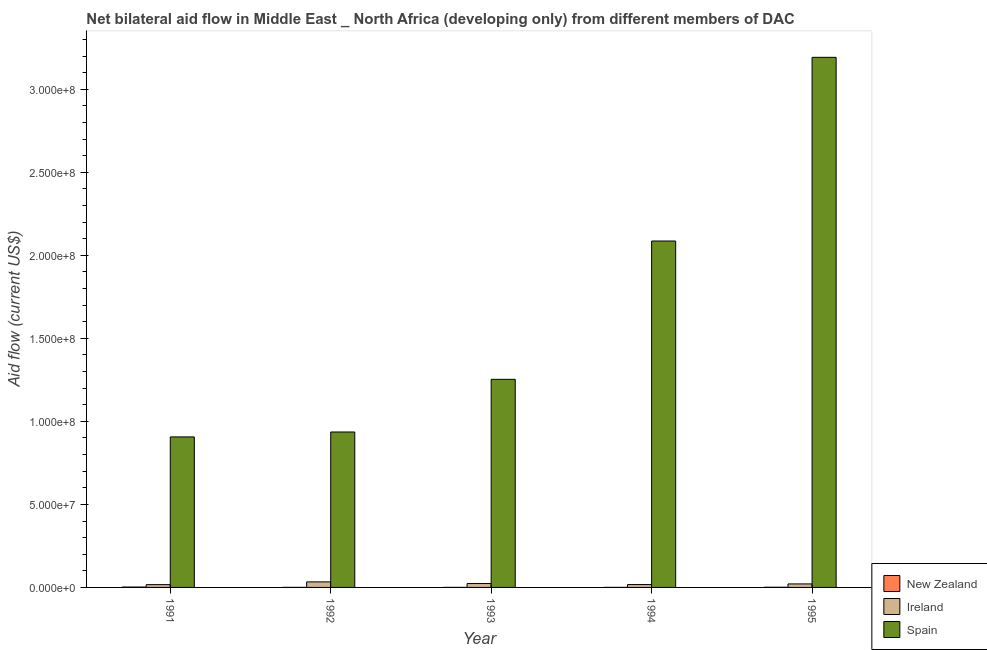How many different coloured bars are there?
Keep it short and to the point. 3. Are the number of bars per tick equal to the number of legend labels?
Provide a short and direct response. Yes. In how many cases, is the number of bars for a given year not equal to the number of legend labels?
Make the answer very short. 0. What is the amount of aid provided by spain in 1995?
Provide a short and direct response. 3.19e+08. Across all years, what is the maximum amount of aid provided by new zealand?
Offer a terse response. 2.20e+05. Across all years, what is the minimum amount of aid provided by spain?
Your answer should be very brief. 9.06e+07. In which year was the amount of aid provided by ireland minimum?
Your answer should be very brief. 1991. What is the total amount of aid provided by spain in the graph?
Your response must be concise. 8.37e+08. What is the difference between the amount of aid provided by new zealand in 1992 and that in 1995?
Your response must be concise. -7.00e+04. What is the difference between the amount of aid provided by ireland in 1994 and the amount of aid provided by new zealand in 1995?
Your answer should be very brief. -3.80e+05. What is the average amount of aid provided by ireland per year?
Offer a very short reply. 2.24e+06. In how many years, is the amount of aid provided by ireland greater than 260000000 US$?
Provide a succinct answer. 0. What is the ratio of the amount of aid provided by ireland in 1991 to that in 1993?
Provide a succinct answer. 0.72. What is the difference between the highest and the second highest amount of aid provided by spain?
Your response must be concise. 1.11e+08. What is the difference between the highest and the lowest amount of aid provided by spain?
Provide a succinct answer. 2.29e+08. In how many years, is the amount of aid provided by spain greater than the average amount of aid provided by spain taken over all years?
Offer a terse response. 2. Is the sum of the amount of aid provided by ireland in 1991 and 1992 greater than the maximum amount of aid provided by new zealand across all years?
Ensure brevity in your answer.  Yes. What does the 1st bar from the left in 1995 represents?
Your response must be concise. New Zealand. What does the 2nd bar from the right in 1994 represents?
Your answer should be very brief. Ireland. Are all the bars in the graph horizontal?
Offer a terse response. No. How many years are there in the graph?
Your answer should be very brief. 5. Are the values on the major ticks of Y-axis written in scientific E-notation?
Offer a terse response. Yes. Does the graph contain any zero values?
Keep it short and to the point. No. Where does the legend appear in the graph?
Your answer should be very brief. Bottom right. How are the legend labels stacked?
Your answer should be compact. Vertical. What is the title of the graph?
Offer a very short reply. Net bilateral aid flow in Middle East _ North Africa (developing only) from different members of DAC. Does "Capital account" appear as one of the legend labels in the graph?
Your response must be concise. No. What is the label or title of the Y-axis?
Ensure brevity in your answer.  Aid flow (current US$). What is the Aid flow (current US$) in New Zealand in 1991?
Provide a succinct answer. 2.20e+05. What is the Aid flow (current US$) of Ireland in 1991?
Your answer should be compact. 1.68e+06. What is the Aid flow (current US$) in Spain in 1991?
Offer a terse response. 9.06e+07. What is the Aid flow (current US$) in New Zealand in 1992?
Make the answer very short. 3.00e+04. What is the Aid flow (current US$) of Ireland in 1992?
Offer a very short reply. 3.33e+06. What is the Aid flow (current US$) in Spain in 1992?
Your answer should be very brief. 9.36e+07. What is the Aid flow (current US$) in New Zealand in 1993?
Your answer should be very brief. 2.00e+04. What is the Aid flow (current US$) in Ireland in 1993?
Ensure brevity in your answer.  2.34e+06. What is the Aid flow (current US$) of Spain in 1993?
Provide a short and direct response. 1.25e+08. What is the Aid flow (current US$) in Ireland in 1994?
Keep it short and to the point. 1.73e+06. What is the Aid flow (current US$) of Spain in 1994?
Your answer should be very brief. 2.09e+08. What is the Aid flow (current US$) in New Zealand in 1995?
Ensure brevity in your answer.  1.00e+05. What is the Aid flow (current US$) of Ireland in 1995?
Make the answer very short. 2.11e+06. What is the Aid flow (current US$) of Spain in 1995?
Keep it short and to the point. 3.19e+08. Across all years, what is the maximum Aid flow (current US$) in Ireland?
Provide a short and direct response. 3.33e+06. Across all years, what is the maximum Aid flow (current US$) of Spain?
Offer a terse response. 3.19e+08. Across all years, what is the minimum Aid flow (current US$) in New Zealand?
Provide a short and direct response. 2.00e+04. Across all years, what is the minimum Aid flow (current US$) in Ireland?
Provide a short and direct response. 1.68e+06. Across all years, what is the minimum Aid flow (current US$) in Spain?
Ensure brevity in your answer.  9.06e+07. What is the total Aid flow (current US$) in New Zealand in the graph?
Make the answer very short. 3.90e+05. What is the total Aid flow (current US$) in Ireland in the graph?
Make the answer very short. 1.12e+07. What is the total Aid flow (current US$) in Spain in the graph?
Your answer should be compact. 8.37e+08. What is the difference between the Aid flow (current US$) in Ireland in 1991 and that in 1992?
Your answer should be compact. -1.65e+06. What is the difference between the Aid flow (current US$) in Spain in 1991 and that in 1992?
Keep it short and to the point. -2.96e+06. What is the difference between the Aid flow (current US$) of Ireland in 1991 and that in 1993?
Your answer should be very brief. -6.60e+05. What is the difference between the Aid flow (current US$) of Spain in 1991 and that in 1993?
Your response must be concise. -3.47e+07. What is the difference between the Aid flow (current US$) of New Zealand in 1991 and that in 1994?
Your response must be concise. 2.00e+05. What is the difference between the Aid flow (current US$) in Spain in 1991 and that in 1994?
Ensure brevity in your answer.  -1.18e+08. What is the difference between the Aid flow (current US$) in Ireland in 1991 and that in 1995?
Make the answer very short. -4.30e+05. What is the difference between the Aid flow (current US$) in Spain in 1991 and that in 1995?
Keep it short and to the point. -2.29e+08. What is the difference between the Aid flow (current US$) of New Zealand in 1992 and that in 1993?
Provide a short and direct response. 10000. What is the difference between the Aid flow (current US$) of Ireland in 1992 and that in 1993?
Provide a succinct answer. 9.90e+05. What is the difference between the Aid flow (current US$) in Spain in 1992 and that in 1993?
Make the answer very short. -3.17e+07. What is the difference between the Aid flow (current US$) in New Zealand in 1992 and that in 1994?
Provide a short and direct response. 10000. What is the difference between the Aid flow (current US$) of Ireland in 1992 and that in 1994?
Provide a succinct answer. 1.60e+06. What is the difference between the Aid flow (current US$) of Spain in 1992 and that in 1994?
Make the answer very short. -1.15e+08. What is the difference between the Aid flow (current US$) in Ireland in 1992 and that in 1995?
Your answer should be very brief. 1.22e+06. What is the difference between the Aid flow (current US$) in Spain in 1992 and that in 1995?
Provide a succinct answer. -2.26e+08. What is the difference between the Aid flow (current US$) in New Zealand in 1993 and that in 1994?
Give a very brief answer. 0. What is the difference between the Aid flow (current US$) in Spain in 1993 and that in 1994?
Your answer should be very brief. -8.33e+07. What is the difference between the Aid flow (current US$) of New Zealand in 1993 and that in 1995?
Your response must be concise. -8.00e+04. What is the difference between the Aid flow (current US$) of Ireland in 1993 and that in 1995?
Offer a terse response. 2.30e+05. What is the difference between the Aid flow (current US$) of Spain in 1993 and that in 1995?
Provide a succinct answer. -1.94e+08. What is the difference between the Aid flow (current US$) of New Zealand in 1994 and that in 1995?
Your response must be concise. -8.00e+04. What is the difference between the Aid flow (current US$) of Ireland in 1994 and that in 1995?
Ensure brevity in your answer.  -3.80e+05. What is the difference between the Aid flow (current US$) of Spain in 1994 and that in 1995?
Give a very brief answer. -1.11e+08. What is the difference between the Aid flow (current US$) of New Zealand in 1991 and the Aid flow (current US$) of Ireland in 1992?
Provide a succinct answer. -3.11e+06. What is the difference between the Aid flow (current US$) of New Zealand in 1991 and the Aid flow (current US$) of Spain in 1992?
Offer a very short reply. -9.34e+07. What is the difference between the Aid flow (current US$) of Ireland in 1991 and the Aid flow (current US$) of Spain in 1992?
Your response must be concise. -9.19e+07. What is the difference between the Aid flow (current US$) in New Zealand in 1991 and the Aid flow (current US$) in Ireland in 1993?
Keep it short and to the point. -2.12e+06. What is the difference between the Aid flow (current US$) in New Zealand in 1991 and the Aid flow (current US$) in Spain in 1993?
Keep it short and to the point. -1.25e+08. What is the difference between the Aid flow (current US$) in Ireland in 1991 and the Aid flow (current US$) in Spain in 1993?
Keep it short and to the point. -1.24e+08. What is the difference between the Aid flow (current US$) of New Zealand in 1991 and the Aid flow (current US$) of Ireland in 1994?
Your answer should be compact. -1.51e+06. What is the difference between the Aid flow (current US$) of New Zealand in 1991 and the Aid flow (current US$) of Spain in 1994?
Your answer should be very brief. -2.08e+08. What is the difference between the Aid flow (current US$) in Ireland in 1991 and the Aid flow (current US$) in Spain in 1994?
Your answer should be very brief. -2.07e+08. What is the difference between the Aid flow (current US$) of New Zealand in 1991 and the Aid flow (current US$) of Ireland in 1995?
Provide a short and direct response. -1.89e+06. What is the difference between the Aid flow (current US$) in New Zealand in 1991 and the Aid flow (current US$) in Spain in 1995?
Offer a terse response. -3.19e+08. What is the difference between the Aid flow (current US$) in Ireland in 1991 and the Aid flow (current US$) in Spain in 1995?
Provide a short and direct response. -3.18e+08. What is the difference between the Aid flow (current US$) in New Zealand in 1992 and the Aid flow (current US$) in Ireland in 1993?
Offer a terse response. -2.31e+06. What is the difference between the Aid flow (current US$) of New Zealand in 1992 and the Aid flow (current US$) of Spain in 1993?
Your answer should be compact. -1.25e+08. What is the difference between the Aid flow (current US$) in Ireland in 1992 and the Aid flow (current US$) in Spain in 1993?
Provide a short and direct response. -1.22e+08. What is the difference between the Aid flow (current US$) in New Zealand in 1992 and the Aid flow (current US$) in Ireland in 1994?
Your response must be concise. -1.70e+06. What is the difference between the Aid flow (current US$) of New Zealand in 1992 and the Aid flow (current US$) of Spain in 1994?
Give a very brief answer. -2.09e+08. What is the difference between the Aid flow (current US$) in Ireland in 1992 and the Aid flow (current US$) in Spain in 1994?
Ensure brevity in your answer.  -2.05e+08. What is the difference between the Aid flow (current US$) of New Zealand in 1992 and the Aid flow (current US$) of Ireland in 1995?
Give a very brief answer. -2.08e+06. What is the difference between the Aid flow (current US$) in New Zealand in 1992 and the Aid flow (current US$) in Spain in 1995?
Your response must be concise. -3.19e+08. What is the difference between the Aid flow (current US$) of Ireland in 1992 and the Aid flow (current US$) of Spain in 1995?
Give a very brief answer. -3.16e+08. What is the difference between the Aid flow (current US$) in New Zealand in 1993 and the Aid flow (current US$) in Ireland in 1994?
Give a very brief answer. -1.71e+06. What is the difference between the Aid flow (current US$) of New Zealand in 1993 and the Aid flow (current US$) of Spain in 1994?
Provide a succinct answer. -2.09e+08. What is the difference between the Aid flow (current US$) in Ireland in 1993 and the Aid flow (current US$) in Spain in 1994?
Your answer should be very brief. -2.06e+08. What is the difference between the Aid flow (current US$) of New Zealand in 1993 and the Aid flow (current US$) of Ireland in 1995?
Provide a succinct answer. -2.09e+06. What is the difference between the Aid flow (current US$) in New Zealand in 1993 and the Aid flow (current US$) in Spain in 1995?
Provide a short and direct response. -3.19e+08. What is the difference between the Aid flow (current US$) of Ireland in 1993 and the Aid flow (current US$) of Spain in 1995?
Make the answer very short. -3.17e+08. What is the difference between the Aid flow (current US$) in New Zealand in 1994 and the Aid flow (current US$) in Ireland in 1995?
Keep it short and to the point. -2.09e+06. What is the difference between the Aid flow (current US$) in New Zealand in 1994 and the Aid flow (current US$) in Spain in 1995?
Ensure brevity in your answer.  -3.19e+08. What is the difference between the Aid flow (current US$) of Ireland in 1994 and the Aid flow (current US$) of Spain in 1995?
Your answer should be compact. -3.18e+08. What is the average Aid flow (current US$) in New Zealand per year?
Offer a very short reply. 7.80e+04. What is the average Aid flow (current US$) in Ireland per year?
Provide a succinct answer. 2.24e+06. What is the average Aid flow (current US$) in Spain per year?
Give a very brief answer. 1.67e+08. In the year 1991, what is the difference between the Aid flow (current US$) in New Zealand and Aid flow (current US$) in Ireland?
Your answer should be compact. -1.46e+06. In the year 1991, what is the difference between the Aid flow (current US$) in New Zealand and Aid flow (current US$) in Spain?
Your answer should be compact. -9.04e+07. In the year 1991, what is the difference between the Aid flow (current US$) in Ireland and Aid flow (current US$) in Spain?
Provide a short and direct response. -8.90e+07. In the year 1992, what is the difference between the Aid flow (current US$) of New Zealand and Aid flow (current US$) of Ireland?
Give a very brief answer. -3.30e+06. In the year 1992, what is the difference between the Aid flow (current US$) in New Zealand and Aid flow (current US$) in Spain?
Keep it short and to the point. -9.36e+07. In the year 1992, what is the difference between the Aid flow (current US$) of Ireland and Aid flow (current US$) of Spain?
Ensure brevity in your answer.  -9.03e+07. In the year 1993, what is the difference between the Aid flow (current US$) of New Zealand and Aid flow (current US$) of Ireland?
Give a very brief answer. -2.32e+06. In the year 1993, what is the difference between the Aid flow (current US$) of New Zealand and Aid flow (current US$) of Spain?
Offer a terse response. -1.25e+08. In the year 1993, what is the difference between the Aid flow (current US$) of Ireland and Aid flow (current US$) of Spain?
Offer a terse response. -1.23e+08. In the year 1994, what is the difference between the Aid flow (current US$) of New Zealand and Aid flow (current US$) of Ireland?
Offer a very short reply. -1.71e+06. In the year 1994, what is the difference between the Aid flow (current US$) in New Zealand and Aid flow (current US$) in Spain?
Give a very brief answer. -2.09e+08. In the year 1994, what is the difference between the Aid flow (current US$) of Ireland and Aid flow (current US$) of Spain?
Keep it short and to the point. -2.07e+08. In the year 1995, what is the difference between the Aid flow (current US$) of New Zealand and Aid flow (current US$) of Ireland?
Provide a succinct answer. -2.01e+06. In the year 1995, what is the difference between the Aid flow (current US$) in New Zealand and Aid flow (current US$) in Spain?
Offer a very short reply. -3.19e+08. In the year 1995, what is the difference between the Aid flow (current US$) in Ireland and Aid flow (current US$) in Spain?
Your response must be concise. -3.17e+08. What is the ratio of the Aid flow (current US$) of New Zealand in 1991 to that in 1992?
Your answer should be compact. 7.33. What is the ratio of the Aid flow (current US$) in Ireland in 1991 to that in 1992?
Your answer should be very brief. 0.5. What is the ratio of the Aid flow (current US$) in Spain in 1991 to that in 1992?
Keep it short and to the point. 0.97. What is the ratio of the Aid flow (current US$) of Ireland in 1991 to that in 1993?
Ensure brevity in your answer.  0.72. What is the ratio of the Aid flow (current US$) in Spain in 1991 to that in 1993?
Ensure brevity in your answer.  0.72. What is the ratio of the Aid flow (current US$) of New Zealand in 1991 to that in 1994?
Provide a short and direct response. 11. What is the ratio of the Aid flow (current US$) in Ireland in 1991 to that in 1994?
Your answer should be compact. 0.97. What is the ratio of the Aid flow (current US$) of Spain in 1991 to that in 1994?
Give a very brief answer. 0.43. What is the ratio of the Aid flow (current US$) of Ireland in 1991 to that in 1995?
Provide a succinct answer. 0.8. What is the ratio of the Aid flow (current US$) of Spain in 1991 to that in 1995?
Ensure brevity in your answer.  0.28. What is the ratio of the Aid flow (current US$) in New Zealand in 1992 to that in 1993?
Your response must be concise. 1.5. What is the ratio of the Aid flow (current US$) of Ireland in 1992 to that in 1993?
Your response must be concise. 1.42. What is the ratio of the Aid flow (current US$) of Spain in 1992 to that in 1993?
Provide a short and direct response. 0.75. What is the ratio of the Aid flow (current US$) of New Zealand in 1992 to that in 1994?
Your answer should be compact. 1.5. What is the ratio of the Aid flow (current US$) of Ireland in 1992 to that in 1994?
Provide a short and direct response. 1.92. What is the ratio of the Aid flow (current US$) of Spain in 1992 to that in 1994?
Your answer should be compact. 0.45. What is the ratio of the Aid flow (current US$) in Ireland in 1992 to that in 1995?
Provide a short and direct response. 1.58. What is the ratio of the Aid flow (current US$) of Spain in 1992 to that in 1995?
Give a very brief answer. 0.29. What is the ratio of the Aid flow (current US$) in New Zealand in 1993 to that in 1994?
Offer a very short reply. 1. What is the ratio of the Aid flow (current US$) in Ireland in 1993 to that in 1994?
Give a very brief answer. 1.35. What is the ratio of the Aid flow (current US$) of Spain in 1993 to that in 1994?
Keep it short and to the point. 0.6. What is the ratio of the Aid flow (current US$) of Ireland in 1993 to that in 1995?
Offer a terse response. 1.11. What is the ratio of the Aid flow (current US$) of Spain in 1993 to that in 1995?
Your response must be concise. 0.39. What is the ratio of the Aid flow (current US$) in Ireland in 1994 to that in 1995?
Offer a very short reply. 0.82. What is the ratio of the Aid flow (current US$) in Spain in 1994 to that in 1995?
Your answer should be very brief. 0.65. What is the difference between the highest and the second highest Aid flow (current US$) in Ireland?
Offer a terse response. 9.90e+05. What is the difference between the highest and the second highest Aid flow (current US$) of Spain?
Your answer should be compact. 1.11e+08. What is the difference between the highest and the lowest Aid flow (current US$) of New Zealand?
Keep it short and to the point. 2.00e+05. What is the difference between the highest and the lowest Aid flow (current US$) of Ireland?
Offer a terse response. 1.65e+06. What is the difference between the highest and the lowest Aid flow (current US$) of Spain?
Your answer should be very brief. 2.29e+08. 